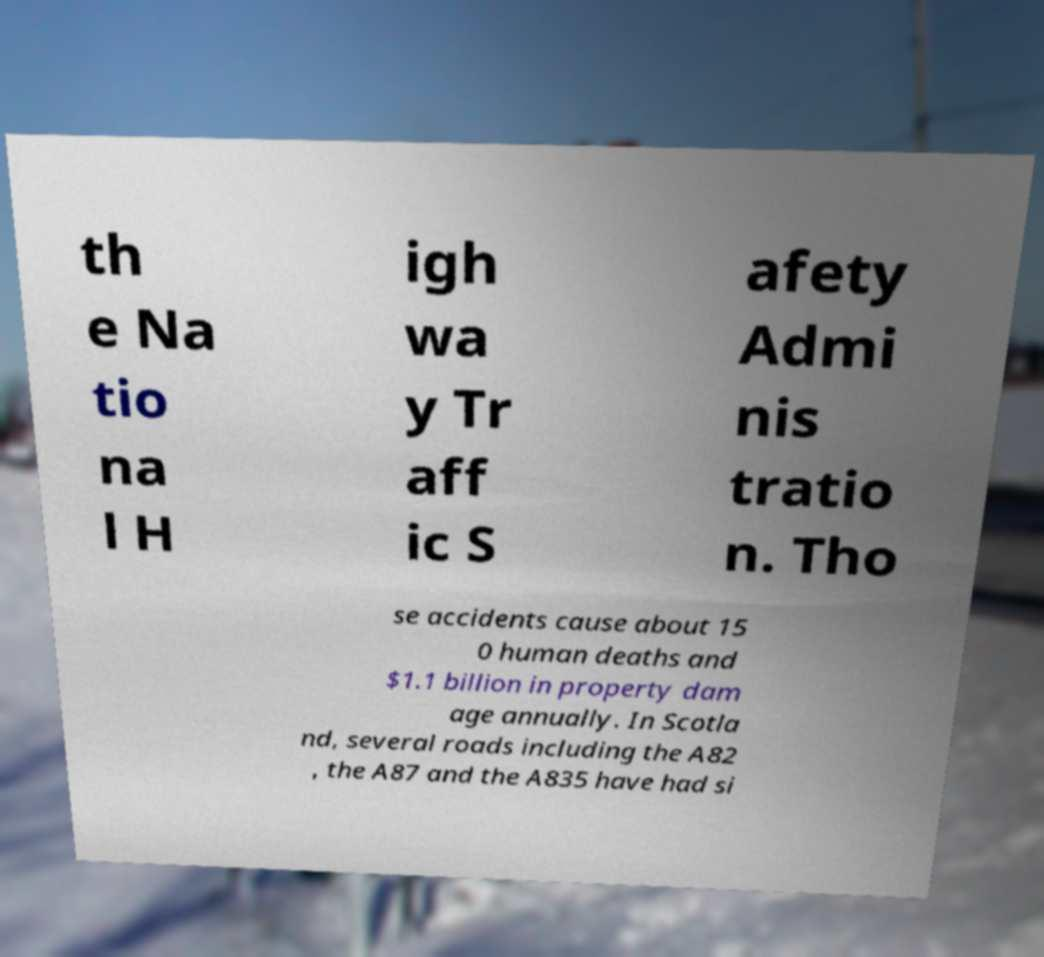I need the written content from this picture converted into text. Can you do that? th e Na tio na l H igh wa y Tr aff ic S afety Admi nis tratio n. Tho se accidents cause about 15 0 human deaths and $1.1 billion in property dam age annually. In Scotla nd, several roads including the A82 , the A87 and the A835 have had si 